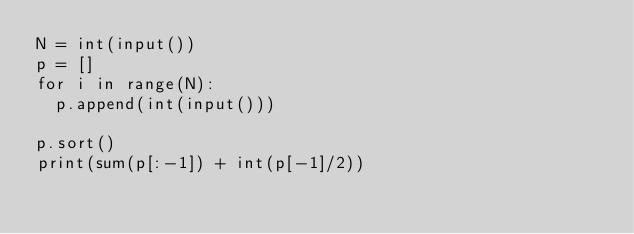<code> <loc_0><loc_0><loc_500><loc_500><_Python_>N = int(input())
p = []
for i in range(N):
  p.append(int(input()))

p.sort()
print(sum(p[:-1]) + int(p[-1]/2))</code> 